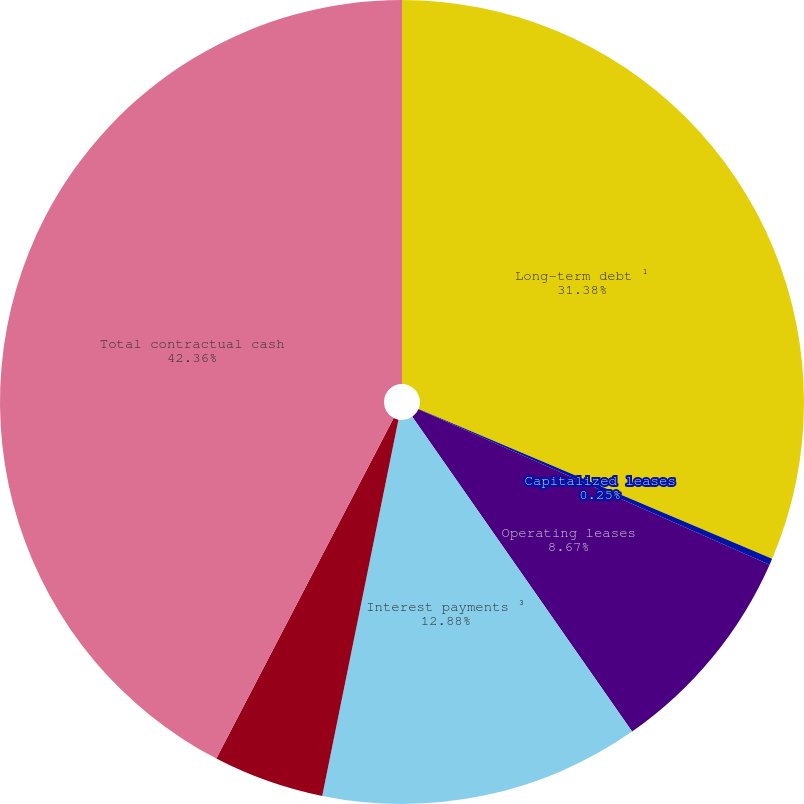<chart> <loc_0><loc_0><loc_500><loc_500><pie_chart><fcel>Long-term debt ¹<fcel>Capitalized leases<fcel>Operating leases<fcel>Interest payments ³<fcel>Other obligations (including<fcel>Total contractual cash<nl><fcel>31.38%<fcel>0.25%<fcel>8.67%<fcel>12.88%<fcel>4.46%<fcel>42.36%<nl></chart> 